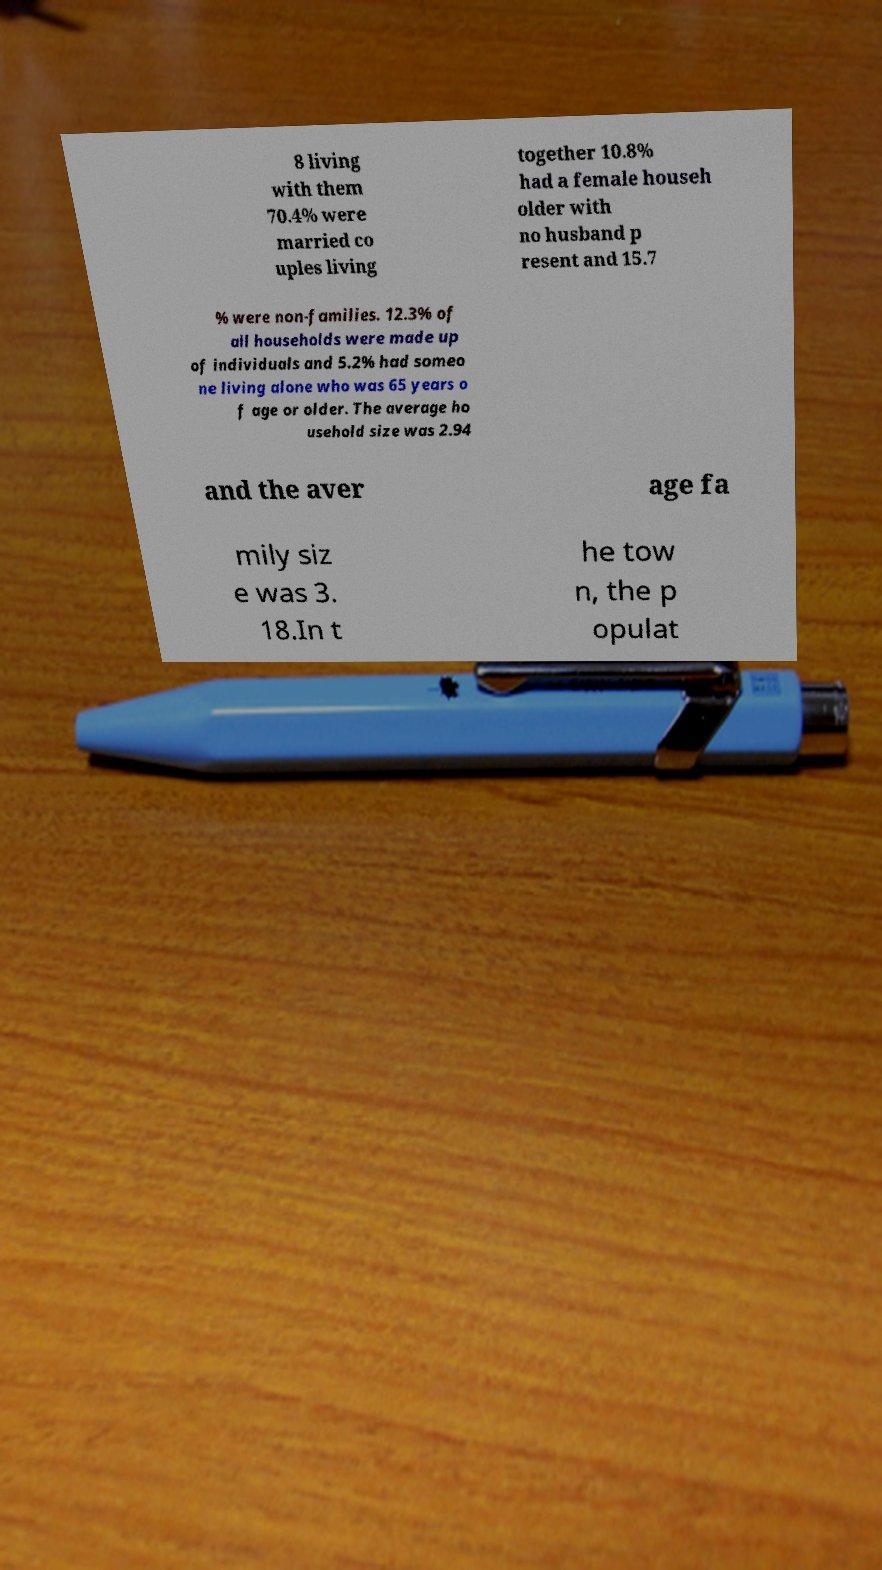Can you read and provide the text displayed in the image?This photo seems to have some interesting text. Can you extract and type it out for me? 8 living with them 70.4% were married co uples living together 10.8% had a female househ older with no husband p resent and 15.7 % were non-families. 12.3% of all households were made up of individuals and 5.2% had someo ne living alone who was 65 years o f age or older. The average ho usehold size was 2.94 and the aver age fa mily siz e was 3. 18.In t he tow n, the p opulat 